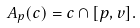<formula> <loc_0><loc_0><loc_500><loc_500>A _ { p } ( c ) = c \cap [ p , v ] .</formula> 